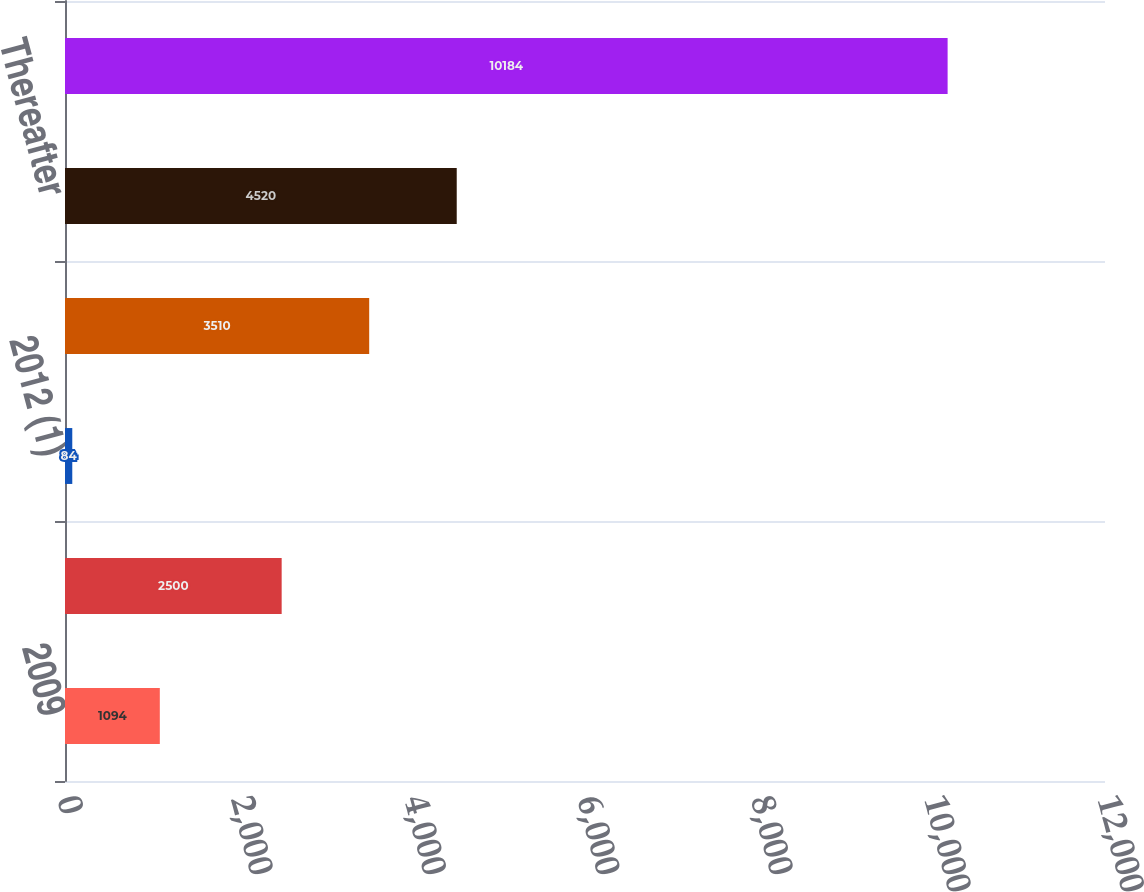<chart> <loc_0><loc_0><loc_500><loc_500><bar_chart><fcel>2009<fcel>2011<fcel>2012 (1)<fcel>2013<fcel>Thereafter<fcel>Total<nl><fcel>1094<fcel>2500<fcel>84<fcel>3510<fcel>4520<fcel>10184<nl></chart> 